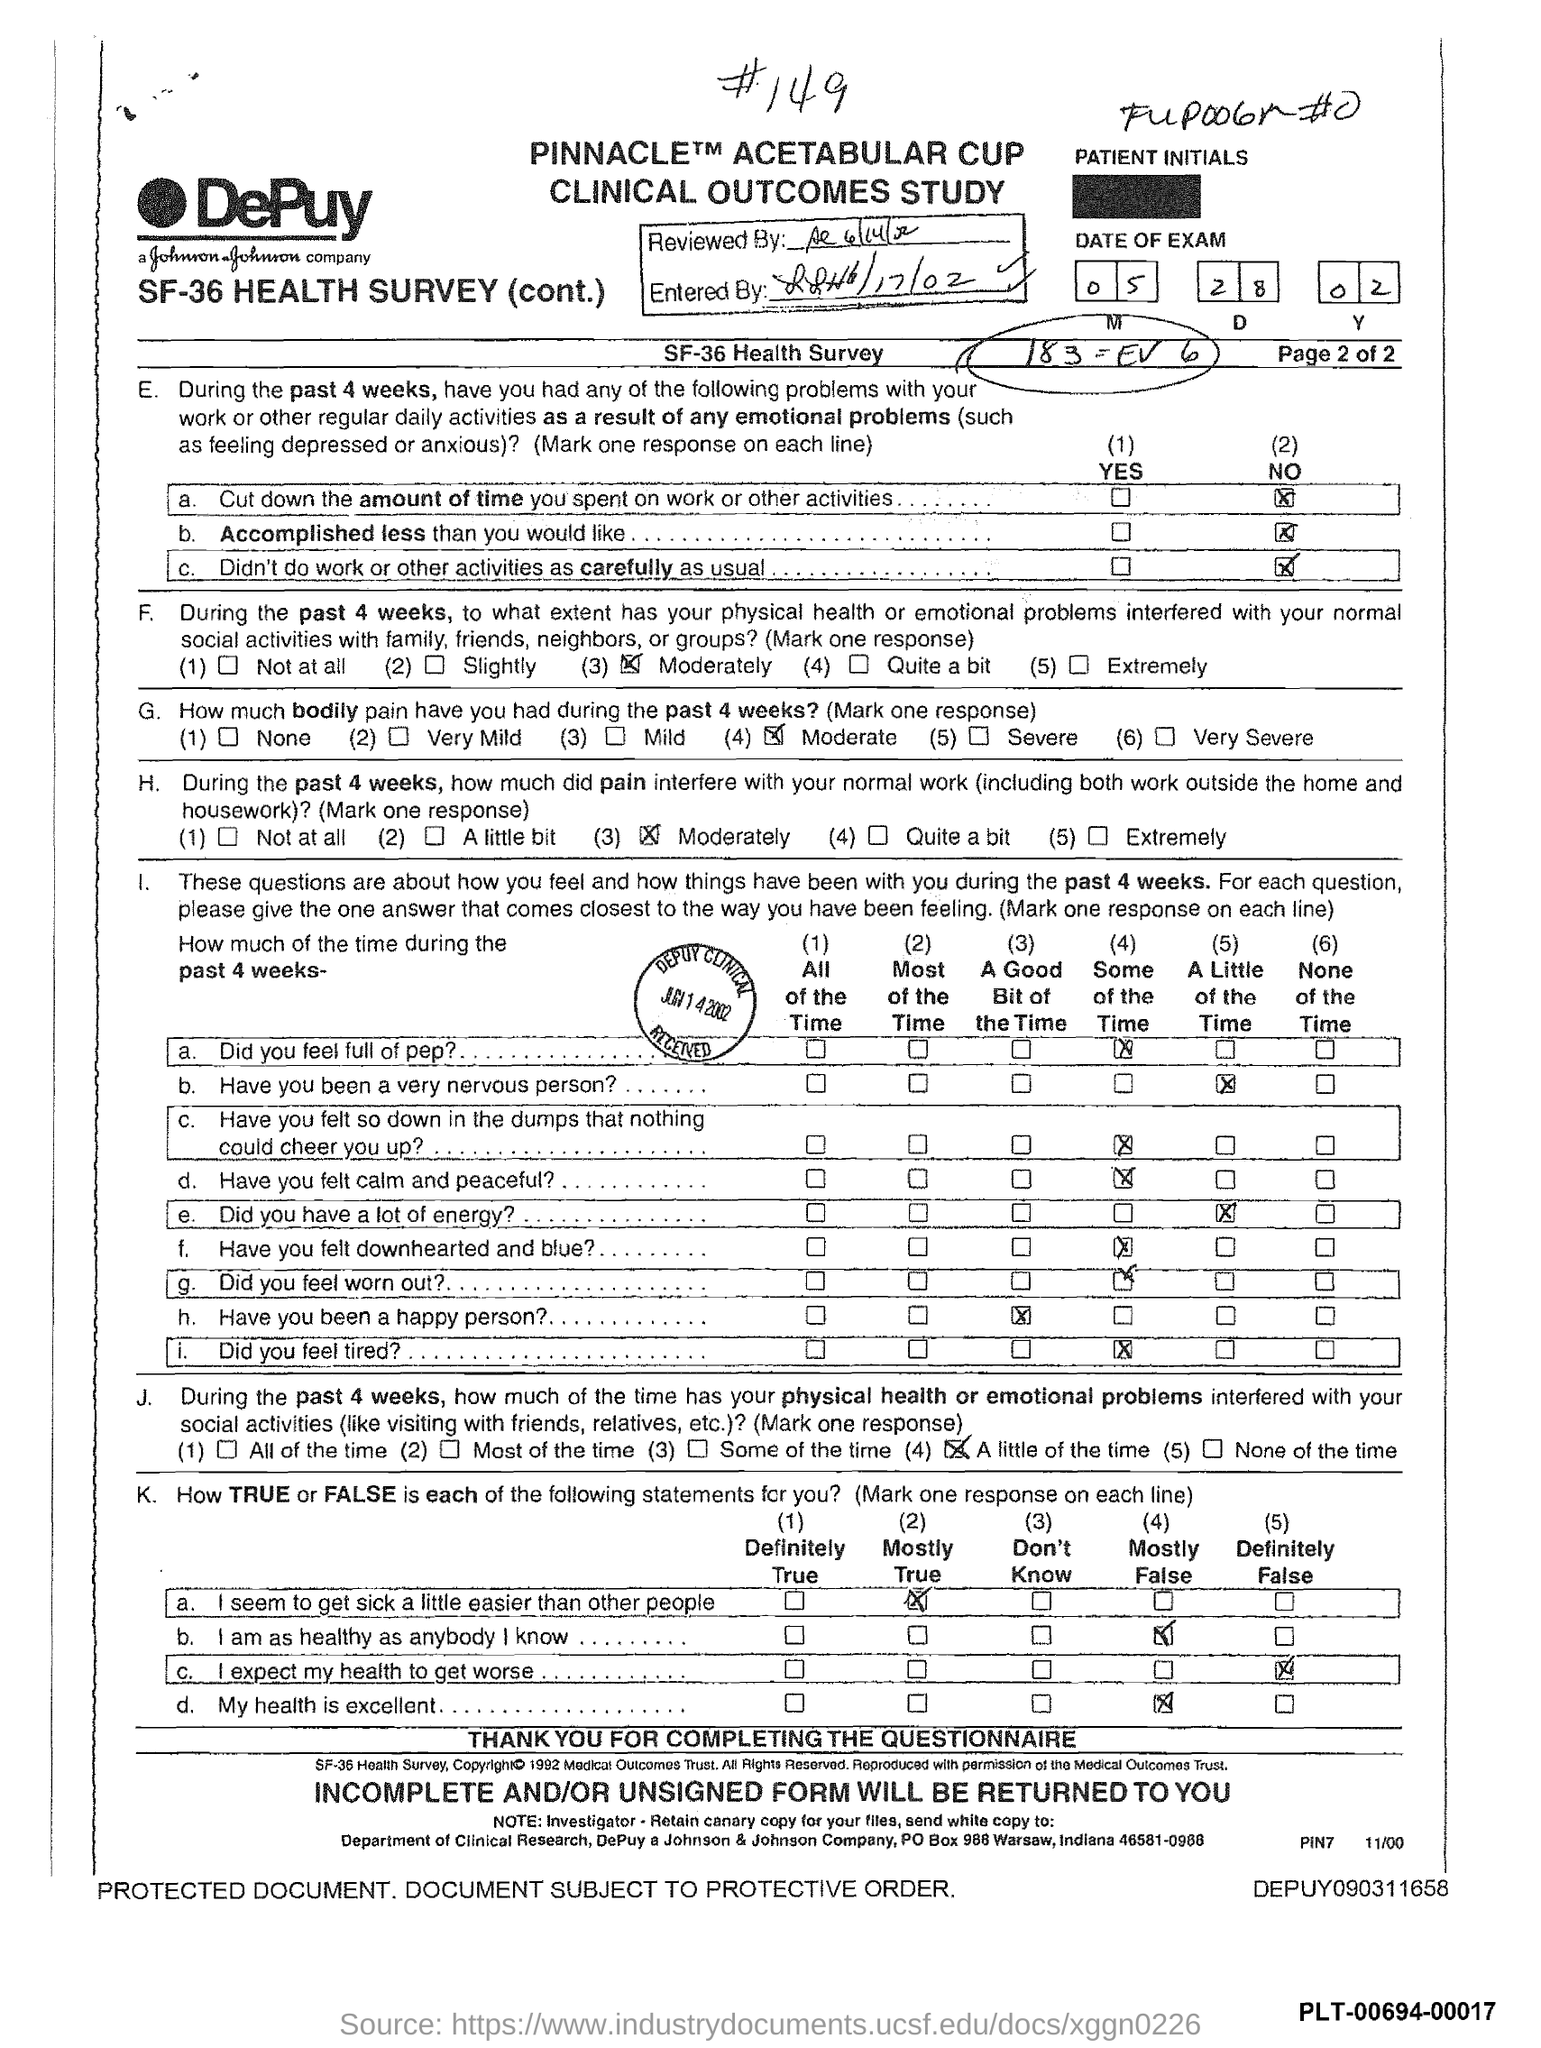What is the month of exam mentioned in the document?
Keep it short and to the point. 05. 